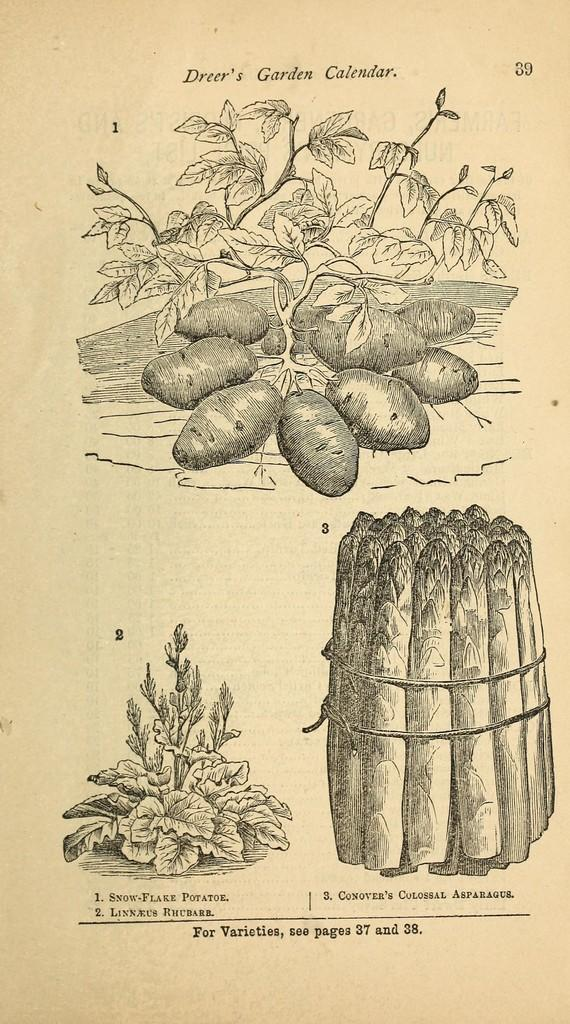What type of arts are depicted in the image? There are arts on paper in the image. What type of bike is featured in the arts on paper? There is no bike present in the image, as it only features arts on paper. 